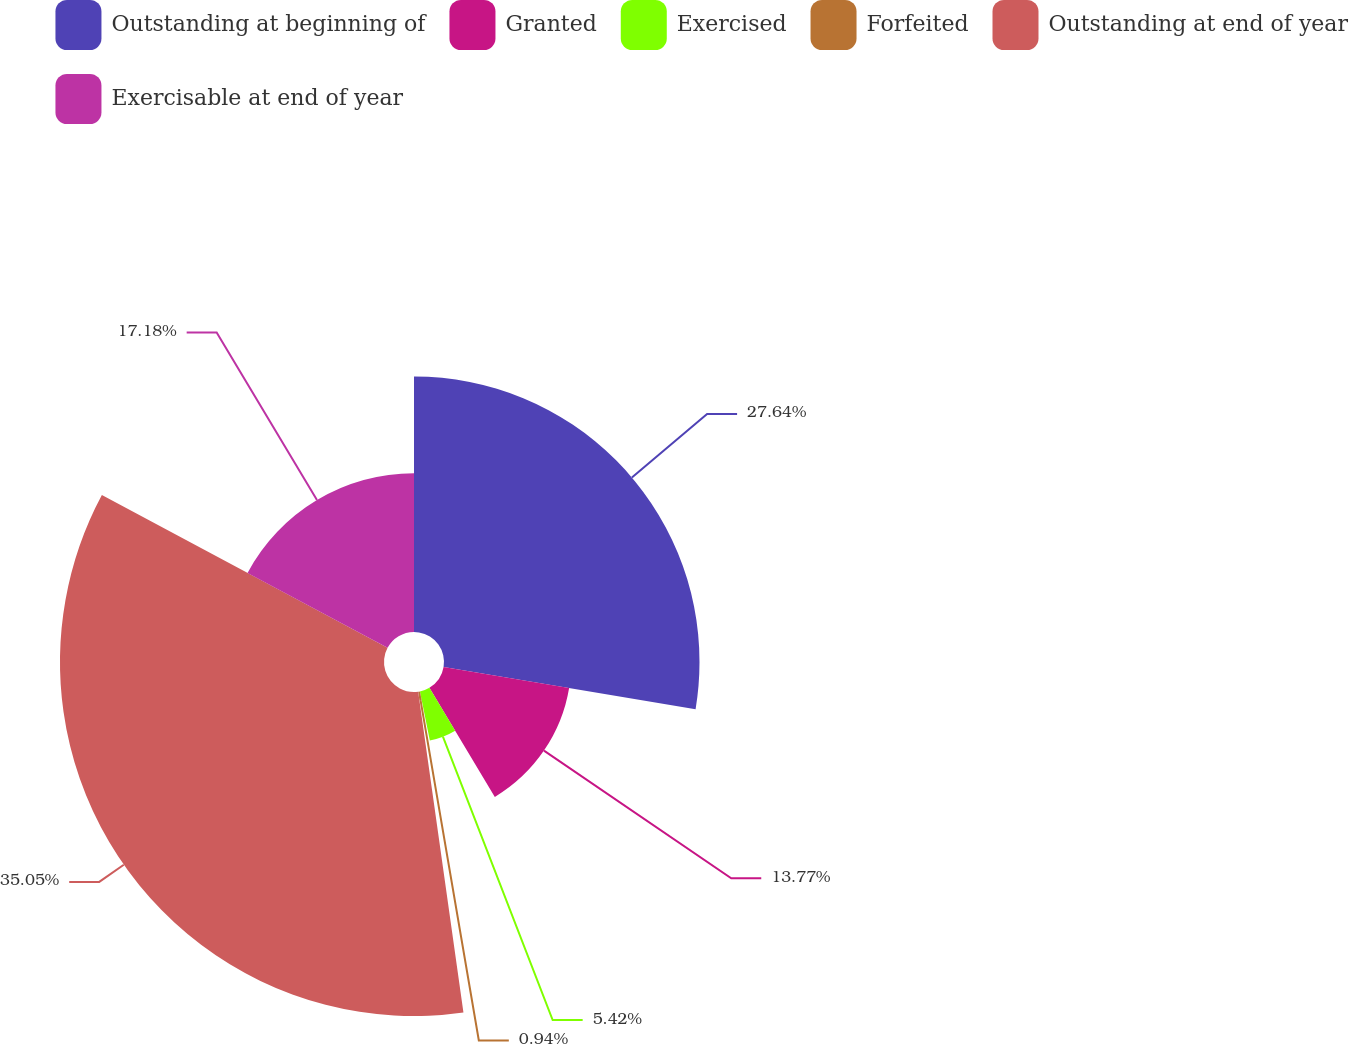Convert chart. <chart><loc_0><loc_0><loc_500><loc_500><pie_chart><fcel>Outstanding at beginning of<fcel>Granted<fcel>Exercised<fcel>Forfeited<fcel>Outstanding at end of year<fcel>Exercisable at end of year<nl><fcel>27.64%<fcel>13.77%<fcel>5.42%<fcel>0.94%<fcel>35.05%<fcel>17.18%<nl></chart> 